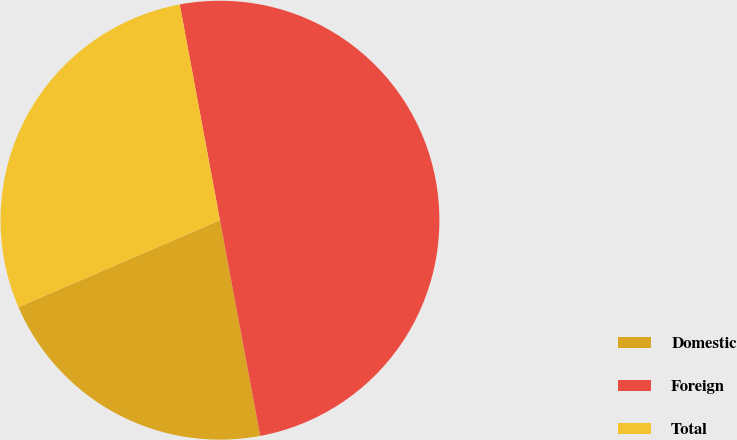Convert chart. <chart><loc_0><loc_0><loc_500><loc_500><pie_chart><fcel>Domestic<fcel>Foreign<fcel>Total<nl><fcel>21.45%<fcel>50.0%<fcel>28.55%<nl></chart> 